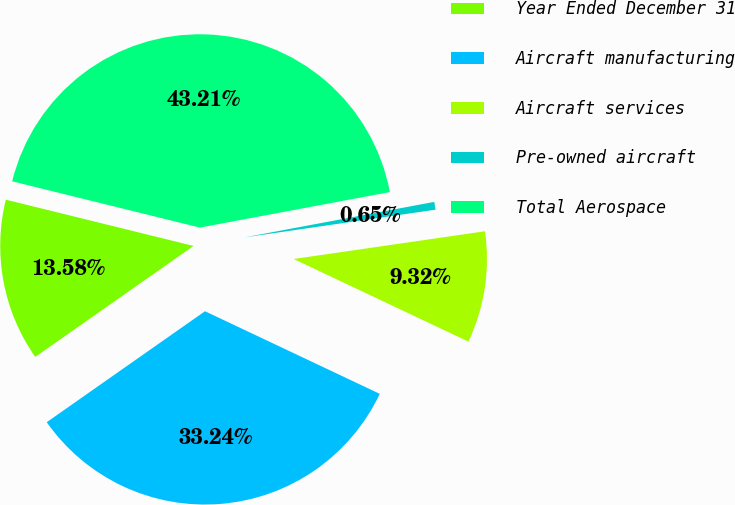Convert chart. <chart><loc_0><loc_0><loc_500><loc_500><pie_chart><fcel>Year Ended December 31<fcel>Aircraft manufacturing<fcel>Aircraft services<fcel>Pre-owned aircraft<fcel>Total Aerospace<nl><fcel>13.58%<fcel>33.24%<fcel>9.32%<fcel>0.65%<fcel>43.21%<nl></chart> 